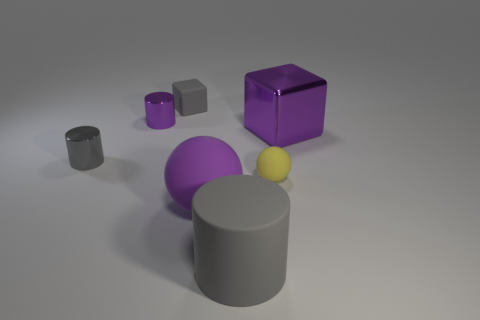There is a small rubber thing that is on the left side of the big gray rubber thing; is its color the same as the large object that is to the right of the yellow matte thing?
Give a very brief answer. No. What number of purple shiny blocks are there?
Provide a succinct answer. 1. There is a small matte sphere; are there any blocks in front of it?
Offer a very short reply. No. Is the small thing in front of the tiny gray shiny object made of the same material as the gray thing that is in front of the tiny gray metallic cylinder?
Provide a short and direct response. Yes. Are there fewer small rubber things in front of the tiny gray cylinder than gray shiny cylinders?
Offer a very short reply. No. The block that is in front of the tiny matte block is what color?
Offer a terse response. Purple. There is a purple thing left of the large rubber thing left of the large gray matte cylinder; what is its material?
Ensure brevity in your answer.  Metal. Is there a yellow object of the same size as the purple ball?
Provide a succinct answer. No. How many things are either tiny gray things that are behind the purple metal cylinder or gray objects behind the large gray object?
Make the answer very short. 2. There is a matte ball that is on the left side of the tiny yellow sphere; is it the same size as the cube that is to the right of the tiny gray cube?
Ensure brevity in your answer.  Yes. 